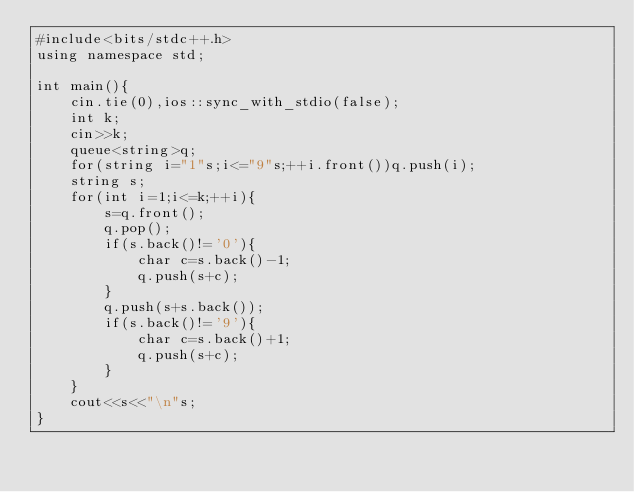Convert code to text. <code><loc_0><loc_0><loc_500><loc_500><_C++_>#include<bits/stdc++.h>
using namespace std;

int main(){
	cin.tie(0),ios::sync_with_stdio(false);
	int k;
	cin>>k;
	queue<string>q;
	for(string i="1"s;i<="9"s;++i.front())q.push(i);
	string s;
	for(int i=1;i<=k;++i){
		s=q.front();
		q.pop();
		if(s.back()!='0'){
			char c=s.back()-1;
			q.push(s+c);
		}
		q.push(s+s.back());
		if(s.back()!='9'){
			char c=s.back()+1;
			q.push(s+c);
		}
	}
	cout<<s<<"\n"s;
}</code> 